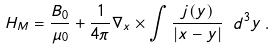<formula> <loc_0><loc_0><loc_500><loc_500>H _ { M } = \frac { B _ { 0 } } { \mu _ { 0 } } + \frac { 1 } { 4 \pi } \nabla _ { x } \times \int \frac { j ( y ) } { \left | x - y \right | } \ d ^ { 3 } y \, .</formula> 